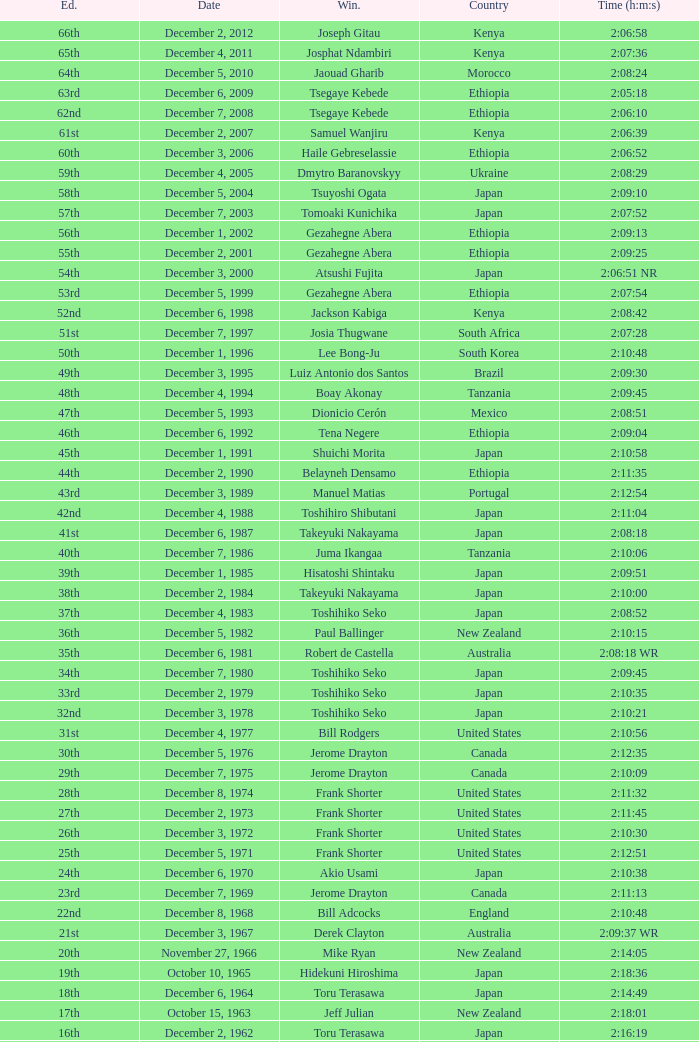On what date was the 48th Edition raced? December 4, 1994. 